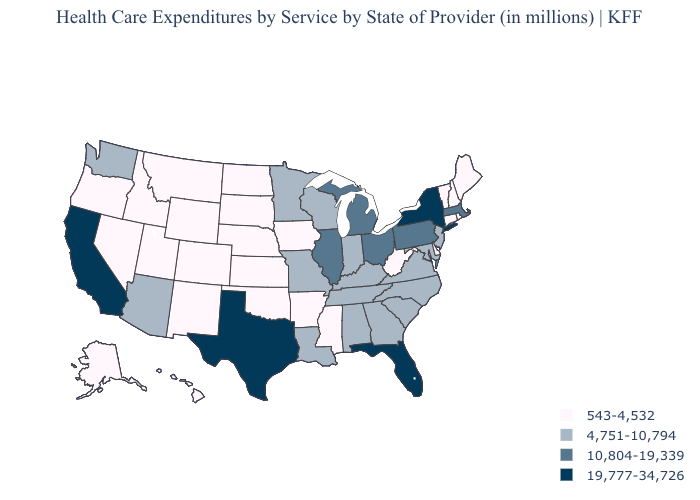Name the states that have a value in the range 10,804-19,339?
Be succinct. Illinois, Massachusetts, Michigan, Ohio, Pennsylvania. Name the states that have a value in the range 543-4,532?
Answer briefly. Alaska, Arkansas, Colorado, Connecticut, Delaware, Hawaii, Idaho, Iowa, Kansas, Maine, Mississippi, Montana, Nebraska, Nevada, New Hampshire, New Mexico, North Dakota, Oklahoma, Oregon, Rhode Island, South Dakota, Utah, Vermont, West Virginia, Wyoming. What is the highest value in the West ?
Concise answer only. 19,777-34,726. What is the value of Mississippi?
Quick response, please. 543-4,532. What is the value of Nebraska?
Keep it brief. 543-4,532. Does North Dakota have the highest value in the MidWest?
Short answer required. No. Does Connecticut have a higher value than Louisiana?
Short answer required. No. Among the states that border Massachusetts , which have the highest value?
Concise answer only. New York. What is the value of Alaska?
Answer briefly. 543-4,532. Is the legend a continuous bar?
Give a very brief answer. No. Among the states that border Iowa , which have the highest value?
Short answer required. Illinois. Among the states that border Indiana , does Kentucky have the lowest value?
Be succinct. Yes. Is the legend a continuous bar?
Quick response, please. No. Does New York have the highest value in the USA?
Give a very brief answer. Yes. What is the lowest value in the USA?
Short answer required. 543-4,532. 